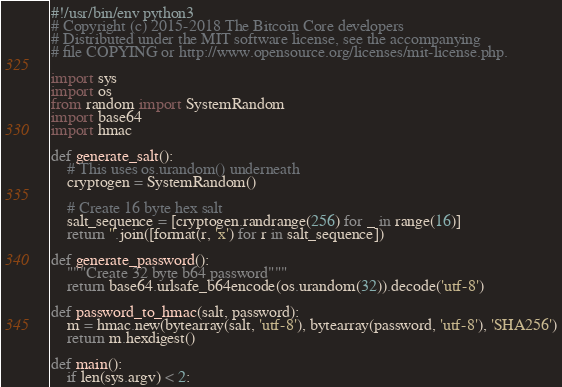<code> <loc_0><loc_0><loc_500><loc_500><_Python_>#!/usr/bin/env python3
# Copyright (c) 2015-2018 The Bitcoin Core developers
# Distributed under the MIT software license, see the accompanying
# file COPYING or http://www.opensource.org/licenses/mit-license.php.

import sys
import os
from random import SystemRandom
import base64
import hmac

def generate_salt():
    # This uses os.urandom() underneath
    cryptogen = SystemRandom()

    # Create 16 byte hex salt
    salt_sequence = [cryptogen.randrange(256) for _ in range(16)]
    return ''.join([format(r, 'x') for r in salt_sequence])

def generate_password():
    """Create 32 byte b64 password"""
    return base64.urlsafe_b64encode(os.urandom(32)).decode('utf-8')

def password_to_hmac(salt, password):
    m = hmac.new(bytearray(salt, 'utf-8'), bytearray(password, 'utf-8'), 'SHA256')
    return m.hexdigest()

def main():
    if len(sys.argv) < 2:</code> 